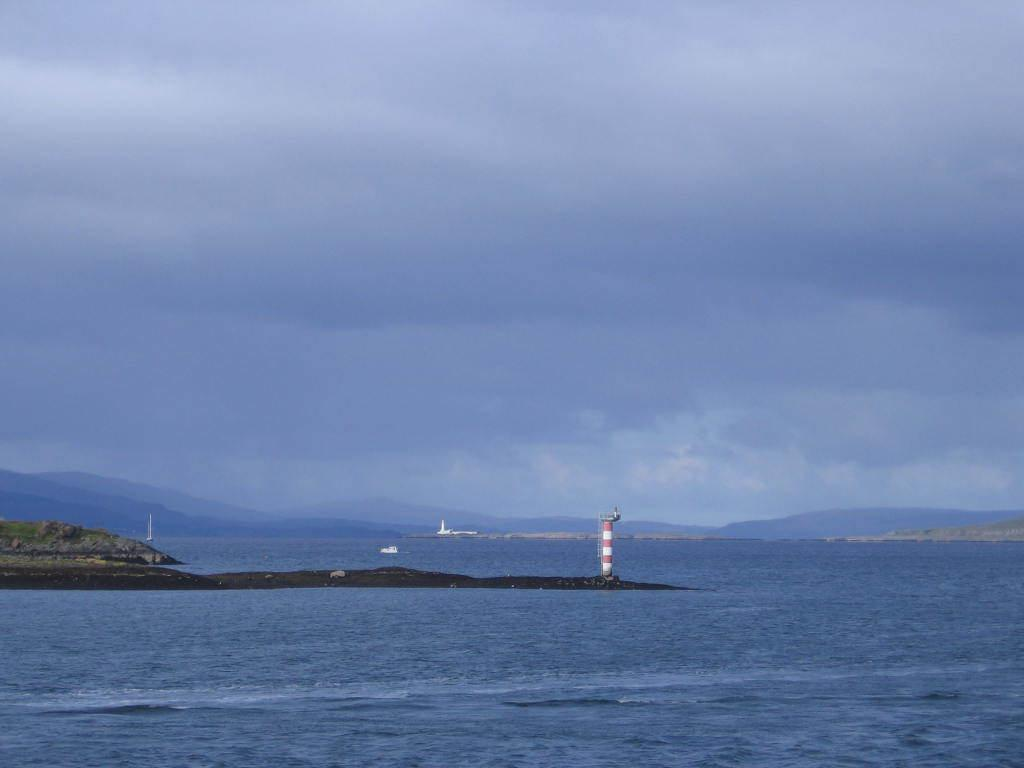What structure is located on the ground in the image? There is a tower on the ground in the image. What is located on water in the image? There is a boat on water in the image. What type of vegetation is visible in the image? There is grass visible in the image. What can be seen in the background of the image? There are mountains and the sky visible in the background of the image. What is present in the sky in the image? Clouds are present in the sky in the image. Can you tell me how many donkeys are grazing in the grass in the image? There are no donkeys present in the image; it features a tower, a boat, grass, mountains, and clouds. What color is the vein visible on the mountain in the image? There is no vein visible on the mountain in the image; it is a geological feature and not a biological one. 